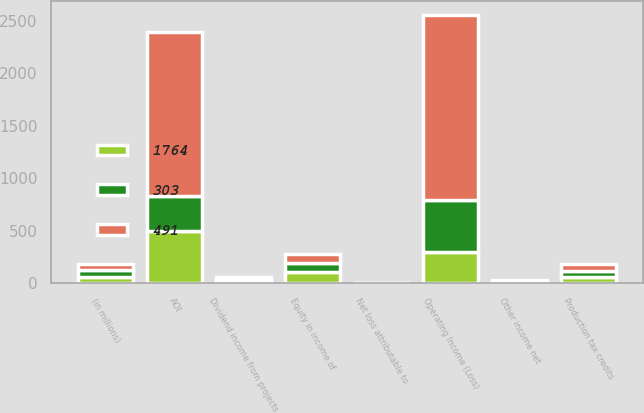Convert chart to OTSL. <chart><loc_0><loc_0><loc_500><loc_500><stacked_bar_chart><ecel><fcel>(in millions)<fcel>AOI<fcel>Equity in income of<fcel>Dividend income from projects<fcel>Production tax credits<fcel>Other income net<fcel>Net loss attributable to<fcel>Operating Income (Loss)<nl><fcel>491<fcel>62<fcel>1561<fcel>86<fcel>31<fcel>66<fcel>19<fcel>1<fcel>1764<nl><fcel>1764<fcel>62<fcel>501<fcel>106<fcel>21<fcel>62<fcel>8<fcel>1<fcel>303<nl><fcel>303<fcel>62<fcel>328<fcel>89<fcel>12<fcel>56<fcel>3<fcel>3<fcel>491<nl></chart> 